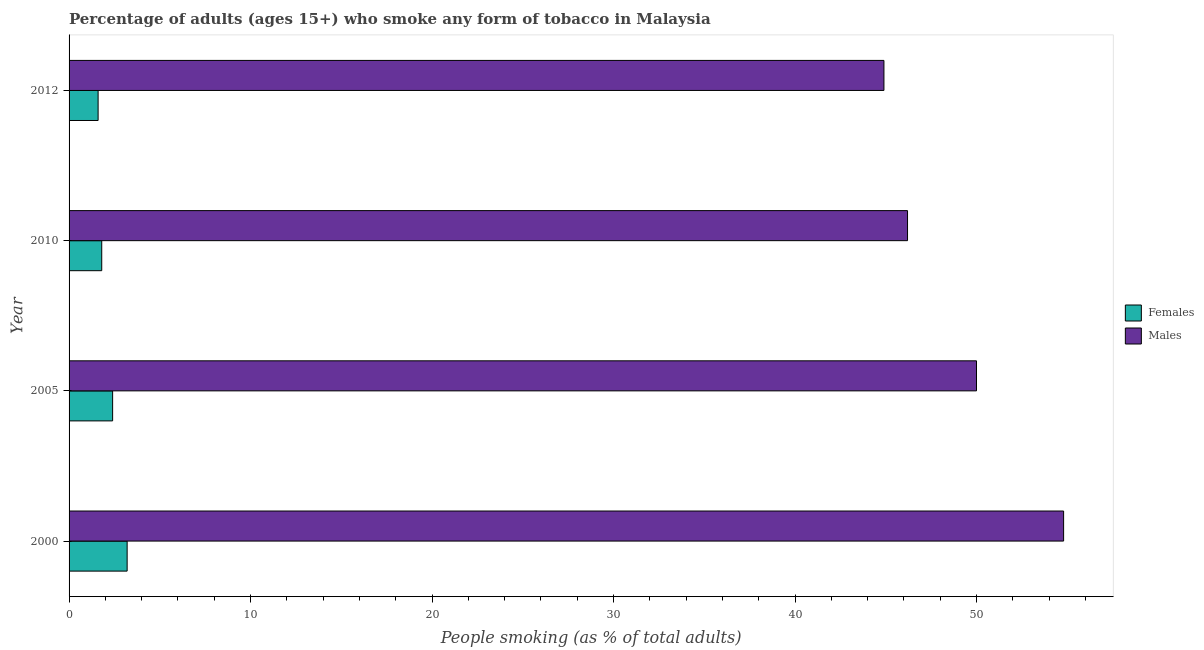Are the number of bars per tick equal to the number of legend labels?
Your response must be concise. Yes. Are the number of bars on each tick of the Y-axis equal?
Make the answer very short. Yes. How many bars are there on the 4th tick from the top?
Offer a very short reply. 2. How many bars are there on the 1st tick from the bottom?
Offer a very short reply. 2. What is the label of the 4th group of bars from the top?
Make the answer very short. 2000. What is the percentage of males who smoke in 2012?
Make the answer very short. 44.9. Across all years, what is the maximum percentage of males who smoke?
Ensure brevity in your answer.  54.8. In which year was the percentage of females who smoke minimum?
Your answer should be very brief. 2012. What is the total percentage of females who smoke in the graph?
Make the answer very short. 9. What is the difference between the percentage of males who smoke in 2010 and that in 2012?
Ensure brevity in your answer.  1.3. What is the average percentage of females who smoke per year?
Offer a very short reply. 2.25. In the year 2012, what is the difference between the percentage of males who smoke and percentage of females who smoke?
Offer a terse response. 43.3. What is the ratio of the percentage of females who smoke in 2005 to that in 2010?
Make the answer very short. 1.33. Is the percentage of females who smoke in 2010 less than that in 2012?
Give a very brief answer. No. Is the difference between the percentage of males who smoke in 2010 and 2012 greater than the difference between the percentage of females who smoke in 2010 and 2012?
Your response must be concise. Yes. What is the difference between the highest and the lowest percentage of males who smoke?
Provide a short and direct response. 9.9. What does the 2nd bar from the top in 2000 represents?
Keep it short and to the point. Females. What does the 1st bar from the bottom in 2000 represents?
Your answer should be compact. Females. How many bars are there?
Make the answer very short. 8. Are all the bars in the graph horizontal?
Your response must be concise. Yes. How many years are there in the graph?
Your answer should be compact. 4. Are the values on the major ticks of X-axis written in scientific E-notation?
Give a very brief answer. No. Does the graph contain any zero values?
Offer a terse response. No. How are the legend labels stacked?
Keep it short and to the point. Vertical. What is the title of the graph?
Make the answer very short. Percentage of adults (ages 15+) who smoke any form of tobacco in Malaysia. What is the label or title of the X-axis?
Give a very brief answer. People smoking (as % of total adults). What is the People smoking (as % of total adults) in Females in 2000?
Provide a short and direct response. 3.2. What is the People smoking (as % of total adults) in Males in 2000?
Your answer should be compact. 54.8. What is the People smoking (as % of total adults) of Females in 2005?
Your response must be concise. 2.4. What is the People smoking (as % of total adults) in Males in 2005?
Your answer should be very brief. 50. What is the People smoking (as % of total adults) of Females in 2010?
Keep it short and to the point. 1.8. What is the People smoking (as % of total adults) in Males in 2010?
Your response must be concise. 46.2. What is the People smoking (as % of total adults) of Females in 2012?
Keep it short and to the point. 1.6. What is the People smoking (as % of total adults) of Males in 2012?
Provide a succinct answer. 44.9. Across all years, what is the maximum People smoking (as % of total adults) of Females?
Give a very brief answer. 3.2. Across all years, what is the maximum People smoking (as % of total adults) of Males?
Give a very brief answer. 54.8. Across all years, what is the minimum People smoking (as % of total adults) in Females?
Your answer should be very brief. 1.6. Across all years, what is the minimum People smoking (as % of total adults) of Males?
Offer a very short reply. 44.9. What is the total People smoking (as % of total adults) in Females in the graph?
Ensure brevity in your answer.  9. What is the total People smoking (as % of total adults) of Males in the graph?
Offer a terse response. 195.9. What is the difference between the People smoking (as % of total adults) in Males in 2000 and that in 2005?
Provide a short and direct response. 4.8. What is the difference between the People smoking (as % of total adults) of Females in 2000 and that in 2012?
Your response must be concise. 1.6. What is the difference between the People smoking (as % of total adults) of Females in 2005 and that in 2010?
Your response must be concise. 0.6. What is the difference between the People smoking (as % of total adults) in Males in 2005 and that in 2010?
Your answer should be very brief. 3.8. What is the difference between the People smoking (as % of total adults) in Females in 2005 and that in 2012?
Your answer should be compact. 0.8. What is the difference between the People smoking (as % of total adults) in Males in 2005 and that in 2012?
Your response must be concise. 5.1. What is the difference between the People smoking (as % of total adults) in Males in 2010 and that in 2012?
Make the answer very short. 1.3. What is the difference between the People smoking (as % of total adults) of Females in 2000 and the People smoking (as % of total adults) of Males in 2005?
Provide a succinct answer. -46.8. What is the difference between the People smoking (as % of total adults) in Females in 2000 and the People smoking (as % of total adults) in Males in 2010?
Make the answer very short. -43. What is the difference between the People smoking (as % of total adults) of Females in 2000 and the People smoking (as % of total adults) of Males in 2012?
Ensure brevity in your answer.  -41.7. What is the difference between the People smoking (as % of total adults) in Females in 2005 and the People smoking (as % of total adults) in Males in 2010?
Provide a succinct answer. -43.8. What is the difference between the People smoking (as % of total adults) in Females in 2005 and the People smoking (as % of total adults) in Males in 2012?
Offer a terse response. -42.5. What is the difference between the People smoking (as % of total adults) in Females in 2010 and the People smoking (as % of total adults) in Males in 2012?
Your answer should be very brief. -43.1. What is the average People smoking (as % of total adults) in Females per year?
Your response must be concise. 2.25. What is the average People smoking (as % of total adults) of Males per year?
Ensure brevity in your answer.  48.98. In the year 2000, what is the difference between the People smoking (as % of total adults) of Females and People smoking (as % of total adults) of Males?
Your response must be concise. -51.6. In the year 2005, what is the difference between the People smoking (as % of total adults) in Females and People smoking (as % of total adults) in Males?
Offer a very short reply. -47.6. In the year 2010, what is the difference between the People smoking (as % of total adults) in Females and People smoking (as % of total adults) in Males?
Provide a short and direct response. -44.4. In the year 2012, what is the difference between the People smoking (as % of total adults) in Females and People smoking (as % of total adults) in Males?
Offer a terse response. -43.3. What is the ratio of the People smoking (as % of total adults) in Females in 2000 to that in 2005?
Make the answer very short. 1.33. What is the ratio of the People smoking (as % of total adults) in Males in 2000 to that in 2005?
Ensure brevity in your answer.  1.1. What is the ratio of the People smoking (as % of total adults) in Females in 2000 to that in 2010?
Make the answer very short. 1.78. What is the ratio of the People smoking (as % of total adults) in Males in 2000 to that in 2010?
Your answer should be compact. 1.19. What is the ratio of the People smoking (as % of total adults) of Males in 2000 to that in 2012?
Your answer should be very brief. 1.22. What is the ratio of the People smoking (as % of total adults) of Females in 2005 to that in 2010?
Provide a succinct answer. 1.33. What is the ratio of the People smoking (as % of total adults) of Males in 2005 to that in 2010?
Make the answer very short. 1.08. What is the ratio of the People smoking (as % of total adults) in Females in 2005 to that in 2012?
Your answer should be compact. 1.5. What is the ratio of the People smoking (as % of total adults) of Males in 2005 to that in 2012?
Provide a succinct answer. 1.11. What is the ratio of the People smoking (as % of total adults) of Females in 2010 to that in 2012?
Offer a terse response. 1.12. What is the difference between the highest and the second highest People smoking (as % of total adults) in Males?
Ensure brevity in your answer.  4.8. What is the difference between the highest and the lowest People smoking (as % of total adults) in Males?
Make the answer very short. 9.9. 